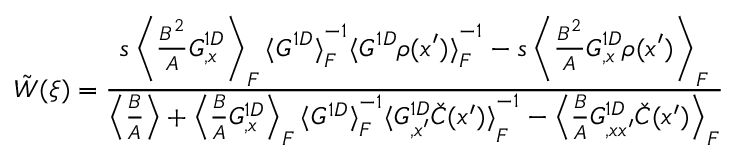Convert formula to latex. <formula><loc_0><loc_0><loc_500><loc_500>\, \tilde { W } ( \xi ) = \frac { s \left \langle { \frac { B ^ { 2 } } { A } G _ { , x } ^ { 1 D } } \right \rangle _ { F } { \langle G ^ { 1 D } \rangle } _ { F } ^ { - 1 } { \langle G ^ { 1 D } \rho ( x ^ { \prime } ) \rangle } _ { F } ^ { - 1 } - s \left \langle { \frac { B ^ { 2 } } { A } G _ { , x } ^ { 1 D } \rho ( x ^ { \prime } ) } \right \rangle _ { F } } { \left \langle { \frac { B } { A } } \right \rangle + \left \langle { \frac { B } { A } G _ { , x } ^ { 1 D } } \right \rangle _ { F } { \langle G ^ { 1 D } \rangle } _ { F } ^ { - 1 } { \langle G _ { , x ^ { \prime } } ^ { 1 D } \check { C } ( x ^ { \prime } ) \rangle } _ { F } ^ { - 1 } - \left \langle { \frac { B } { A } G _ { , x x ^ { \prime } } ^ { 1 D } \check { C } ( x ^ { \prime } ) } \right \rangle _ { F } }</formula> 